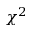Convert formula to latex. <formula><loc_0><loc_0><loc_500><loc_500>\chi ^ { 2 }</formula> 